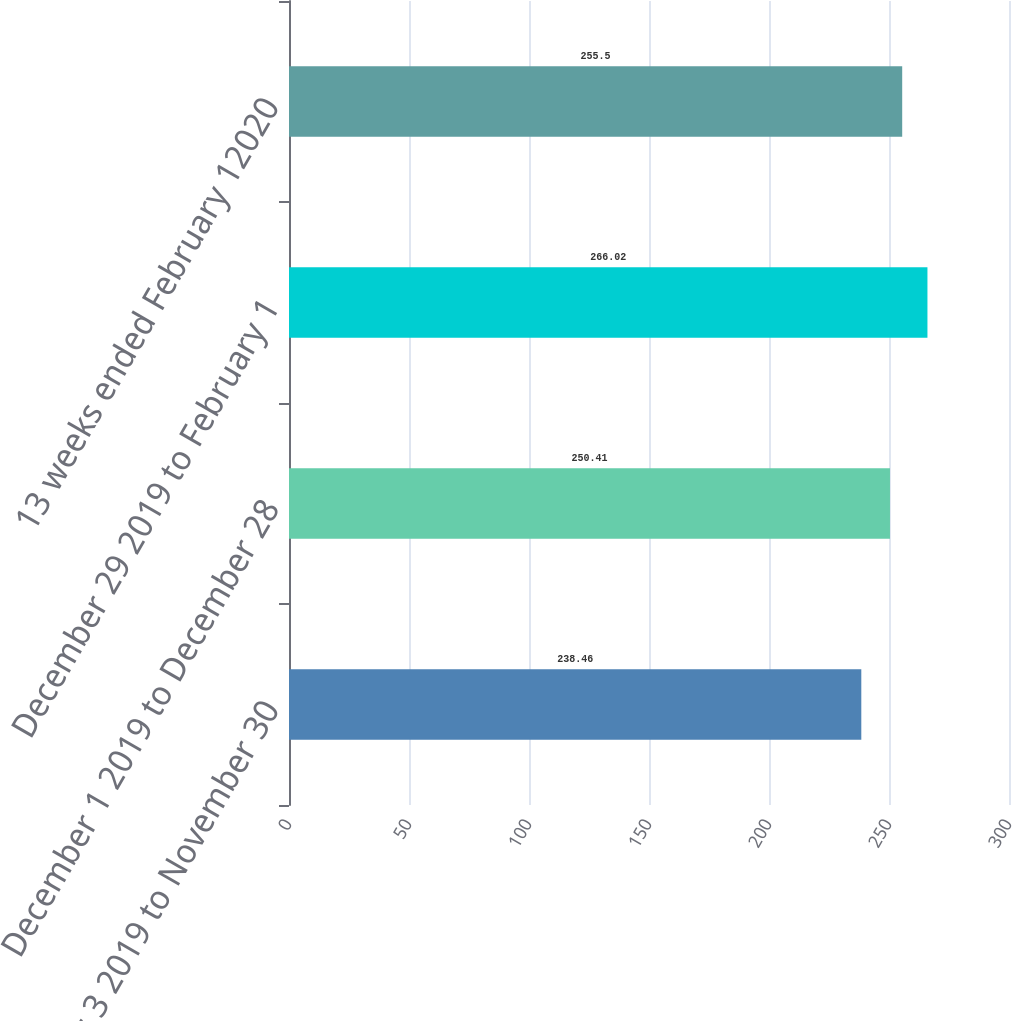<chart> <loc_0><loc_0><loc_500><loc_500><bar_chart><fcel>November 3 2019 to November 30<fcel>December 1 2019 to December 28<fcel>December 29 2019 to February 1<fcel>13 weeks ended February 12020<nl><fcel>238.46<fcel>250.41<fcel>266.02<fcel>255.5<nl></chart> 